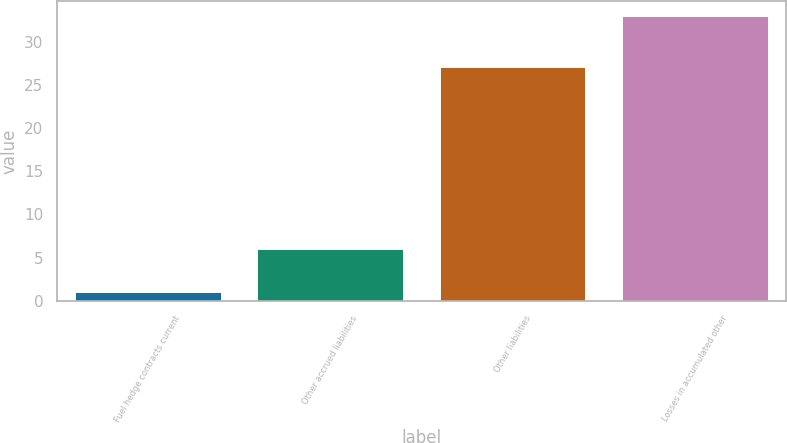Convert chart. <chart><loc_0><loc_0><loc_500><loc_500><bar_chart><fcel>Fuel hedge contracts current<fcel>Other accrued liabilities<fcel>Other liabilities<fcel>Losses in accumulated other<nl><fcel>1<fcel>6<fcel>27<fcel>33<nl></chart> 